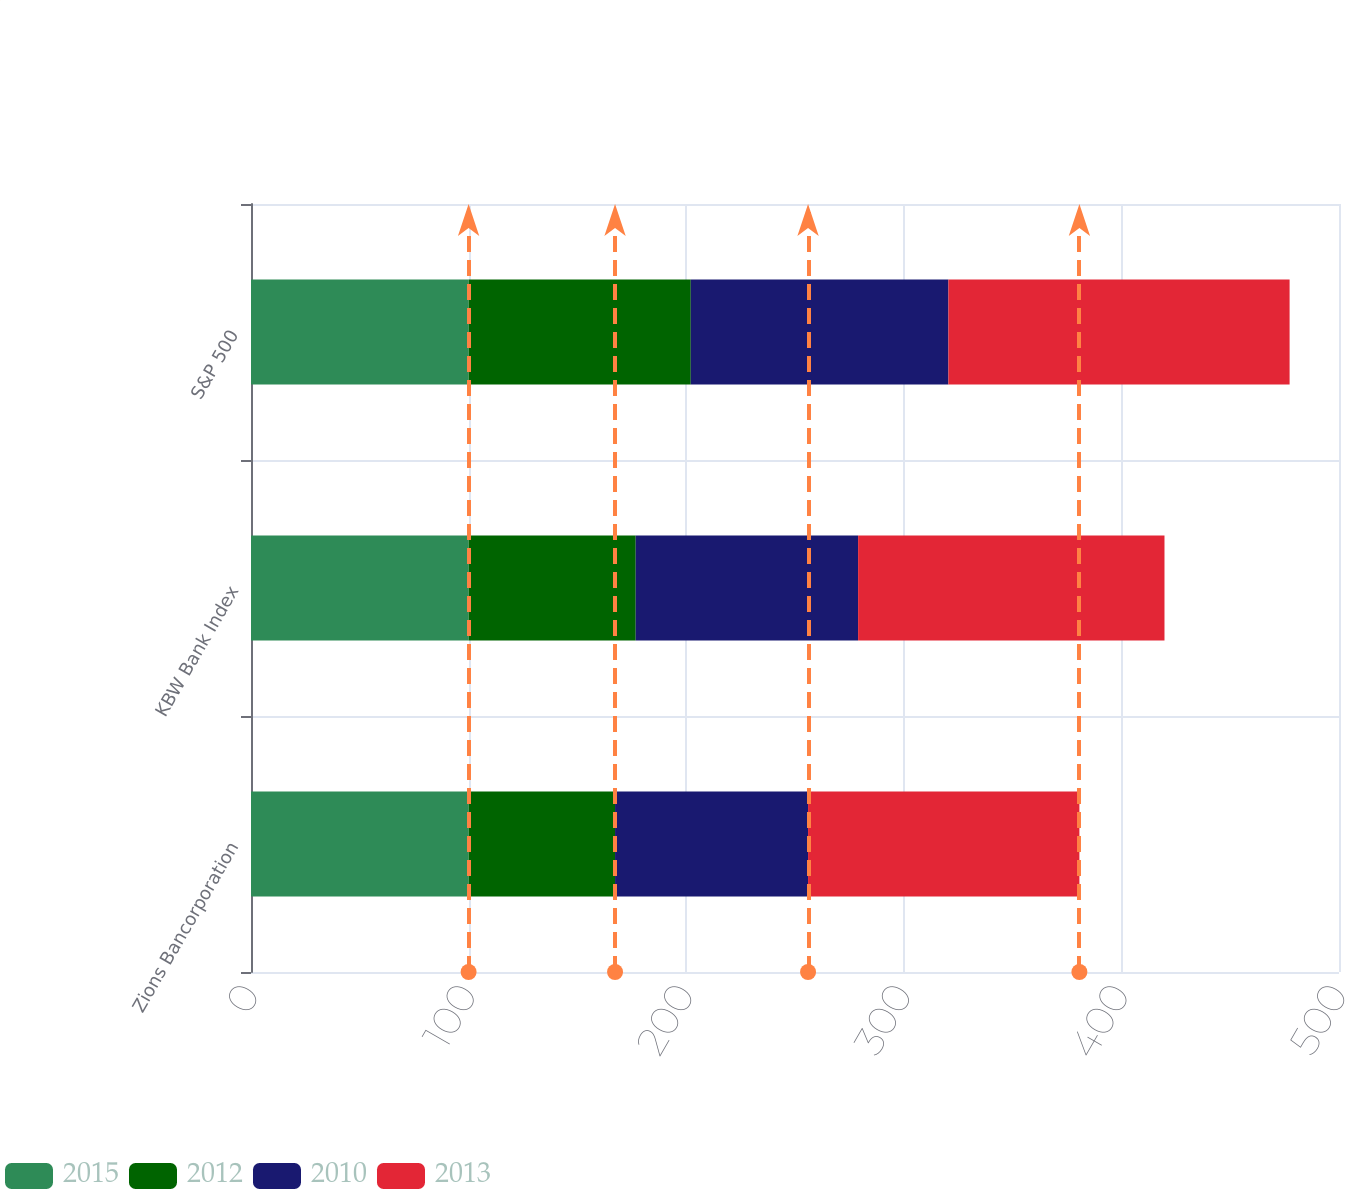<chart> <loc_0><loc_0><loc_500><loc_500><stacked_bar_chart><ecel><fcel>Zions Bancorporation<fcel>KBW Bank Index<fcel>S&P 500<nl><fcel>2015<fcel>100<fcel>100<fcel>100<nl><fcel>2012<fcel>67.3<fcel>76.8<fcel>102.1<nl><fcel>2010<fcel>88.7<fcel>102.2<fcel>118.4<nl><fcel>2013<fcel>124.7<fcel>140.8<fcel>156.8<nl></chart> 